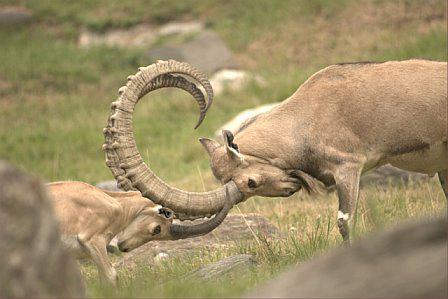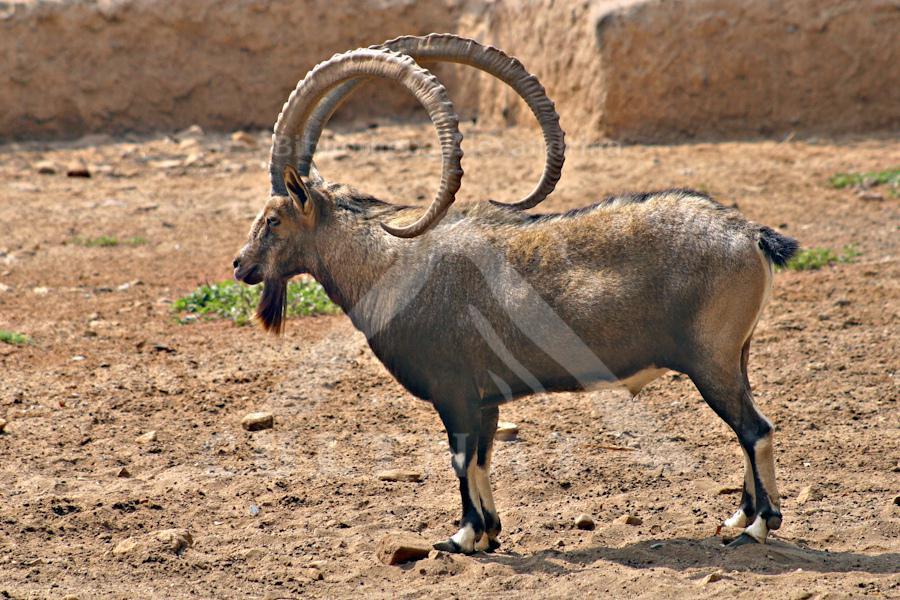The first image is the image on the left, the second image is the image on the right. Analyze the images presented: Is the assertion "The left and right image contains three horned goats." valid? Answer yes or no. Yes. The first image is the image on the left, the second image is the image on the right. Assess this claim about the two images: "In one of the images, the heads of two goats are visible.". Correct or not? Answer yes or no. Yes. 